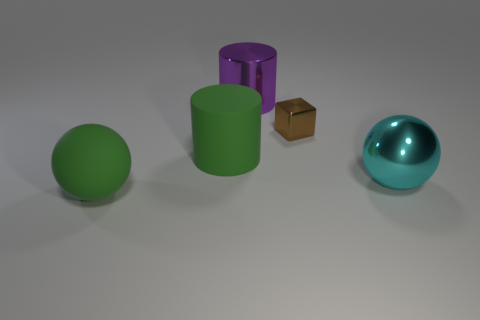How many things are purple shiny things or small rubber objects?
Offer a terse response. 1. Is the number of rubber cylinders greater than the number of brown rubber cylinders?
Your answer should be very brief. Yes. There is a sphere that is on the left side of the metal thing that is in front of the small brown shiny object; what is its size?
Make the answer very short. Large. What is the color of the big rubber thing that is the same shape as the purple shiny object?
Offer a very short reply. Green. The purple cylinder has what size?
Ensure brevity in your answer.  Large. What number of blocks are tiny yellow metal objects or large cyan objects?
Give a very brief answer. 0. How many shiny objects are there?
Your answer should be compact. 3. There is a big purple object; is its shape the same as the green rubber object that is on the right side of the big matte sphere?
Offer a terse response. Yes. What is the size of the brown shiny cube behind the metallic sphere?
Make the answer very short. Small. What material is the green cylinder?
Keep it short and to the point. Rubber. 